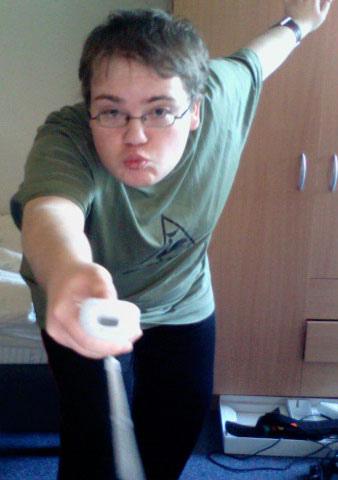What type of remote is the boy holding?
Give a very brief answer. Wii. Which hand is the boy wearing his watch on?
Quick response, please. Left. Is the boy wearing glasses?
Concise answer only. Yes. 